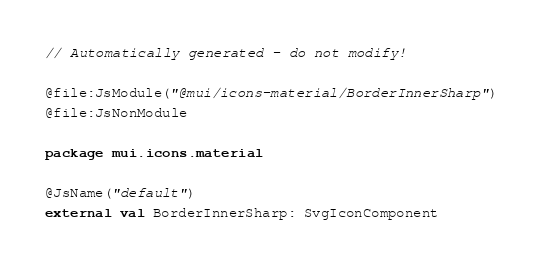<code> <loc_0><loc_0><loc_500><loc_500><_Kotlin_>// Automatically generated - do not modify!

@file:JsModule("@mui/icons-material/BorderInnerSharp")
@file:JsNonModule

package mui.icons.material

@JsName("default")
external val BorderInnerSharp: SvgIconComponent
</code> 